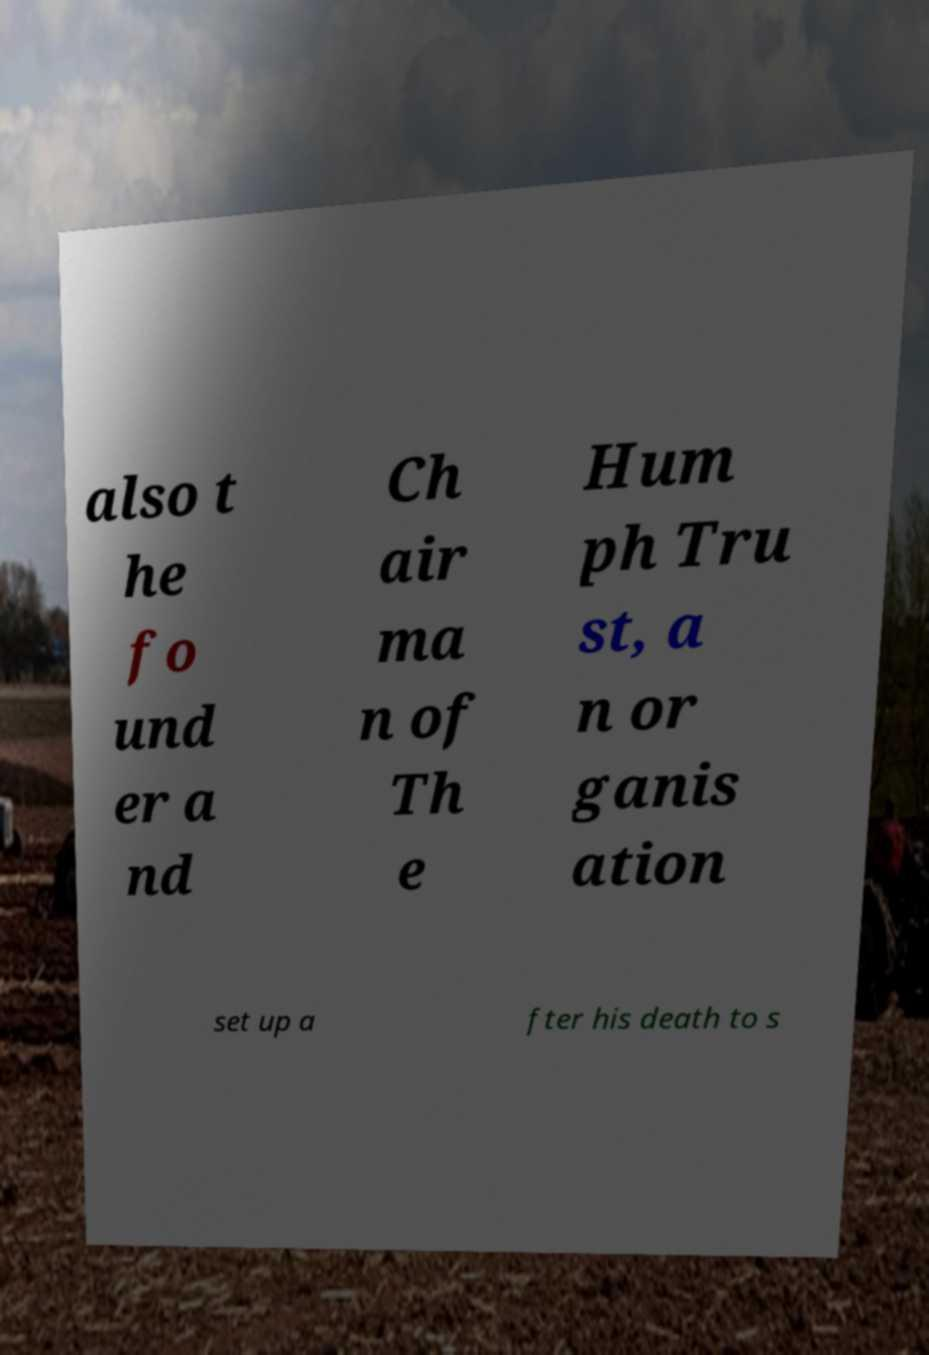Can you accurately transcribe the text from the provided image for me? also t he fo und er a nd Ch air ma n of Th e Hum ph Tru st, a n or ganis ation set up a fter his death to s 